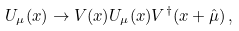Convert formula to latex. <formula><loc_0><loc_0><loc_500><loc_500>U _ { \mu } ( x ) \to V ( x ) U _ { \mu } ( x ) V ^ { \dagger } ( x + \hat { \mu } ) \, ,</formula> 